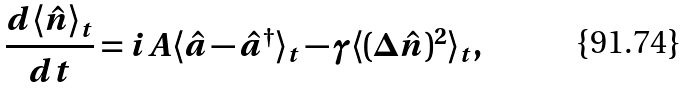<formula> <loc_0><loc_0><loc_500><loc_500>\frac { d \langle \hat { n } \rangle _ { t } } { d t } = i A \langle \hat { a } - \hat { a } ^ { \dagger } \rangle _ { t } - \gamma \langle ( \Delta \hat { n } ) ^ { 2 } \rangle _ { t } ,</formula> 